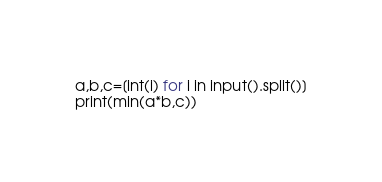<code> <loc_0><loc_0><loc_500><loc_500><_Python_>a,b,c=[int(i) for i in input().split()]
print(min(a*b,c))</code> 